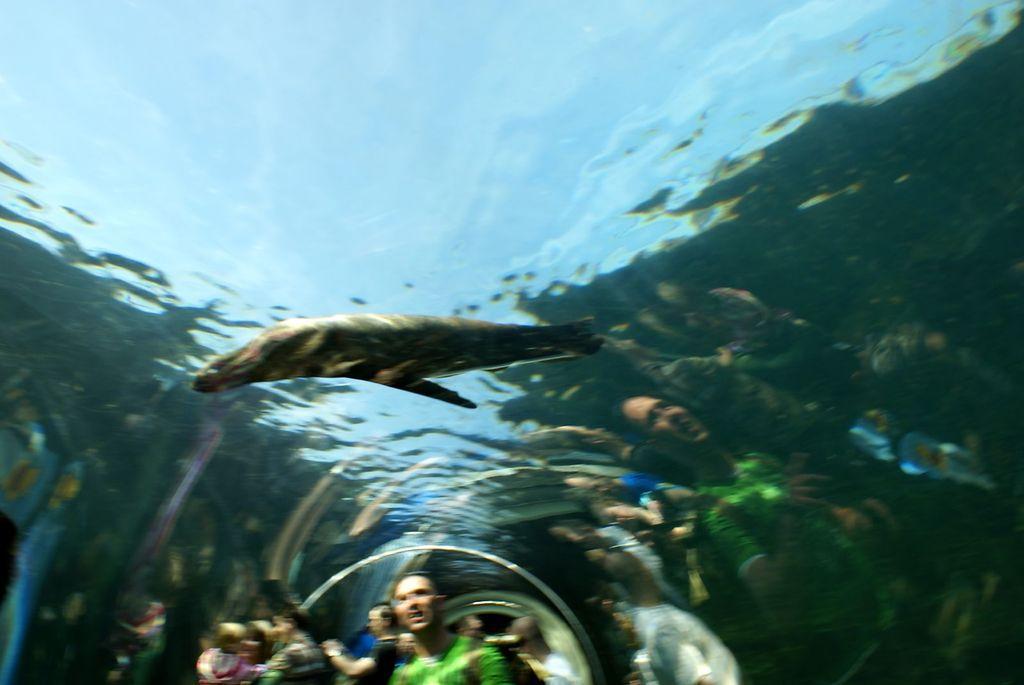Please provide a concise description of this image. In the image we can see a fish in the water. We can even see there are people and they are in the underground water path and the image is slightly blurred. 